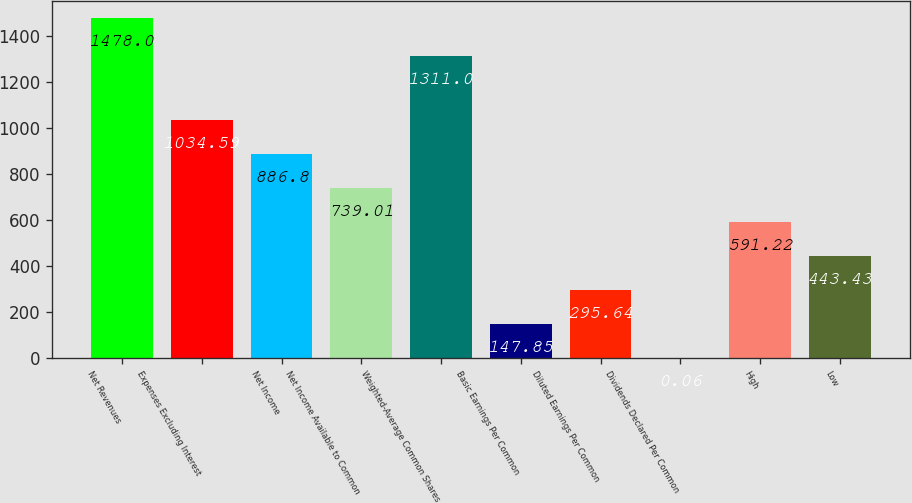Convert chart. <chart><loc_0><loc_0><loc_500><loc_500><bar_chart><fcel>Net Revenues<fcel>Expenses Excluding Interest<fcel>Net Income<fcel>Net Income Available to Common<fcel>Weighted-Average Common Shares<fcel>Basic Earnings Per Common<fcel>Diluted Earnings Per Common<fcel>Dividends Declared Per Common<fcel>High<fcel>Low<nl><fcel>1478<fcel>1034.59<fcel>886.8<fcel>739.01<fcel>1311<fcel>147.85<fcel>295.64<fcel>0.06<fcel>591.22<fcel>443.43<nl></chart> 